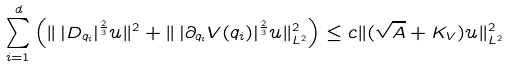Convert formula to latex. <formula><loc_0><loc_0><loc_500><loc_500>{ \sum _ { i = 1 } ^ { d } \left ( \| \, | D _ { q _ { i } } | ^ { \frac { 2 } { 3 } } u \| ^ { 2 } + \| \, | \partial _ { q _ { i } } V ( q _ { i } ) | ^ { \frac { 2 } { 3 } } u \| ^ { 2 } _ { L ^ { 2 } } \right ) } \leq c \| ( \sqrt { A } + K _ { V } ) u \| ^ { 2 } _ { L ^ { 2 } }</formula> 